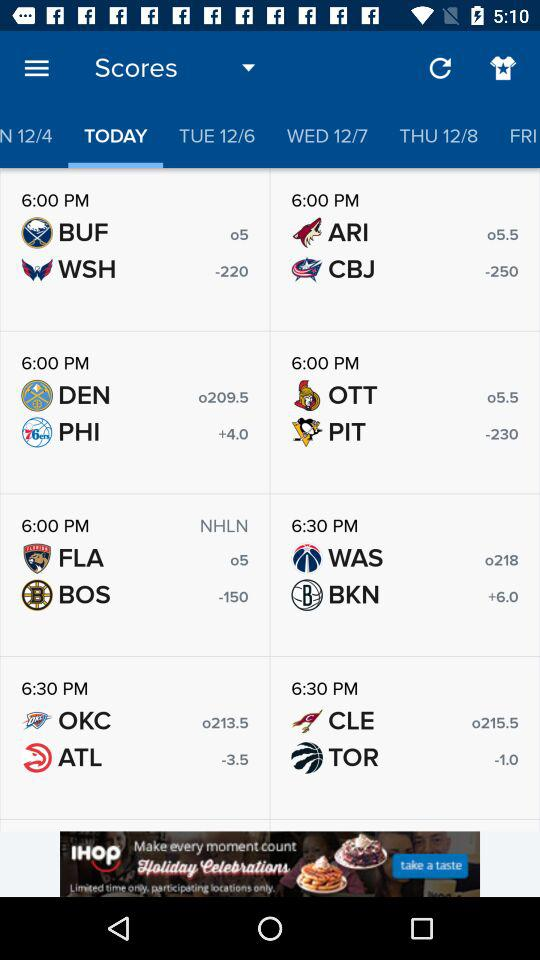Which tab has selected? The selected tab is "TODAY". 